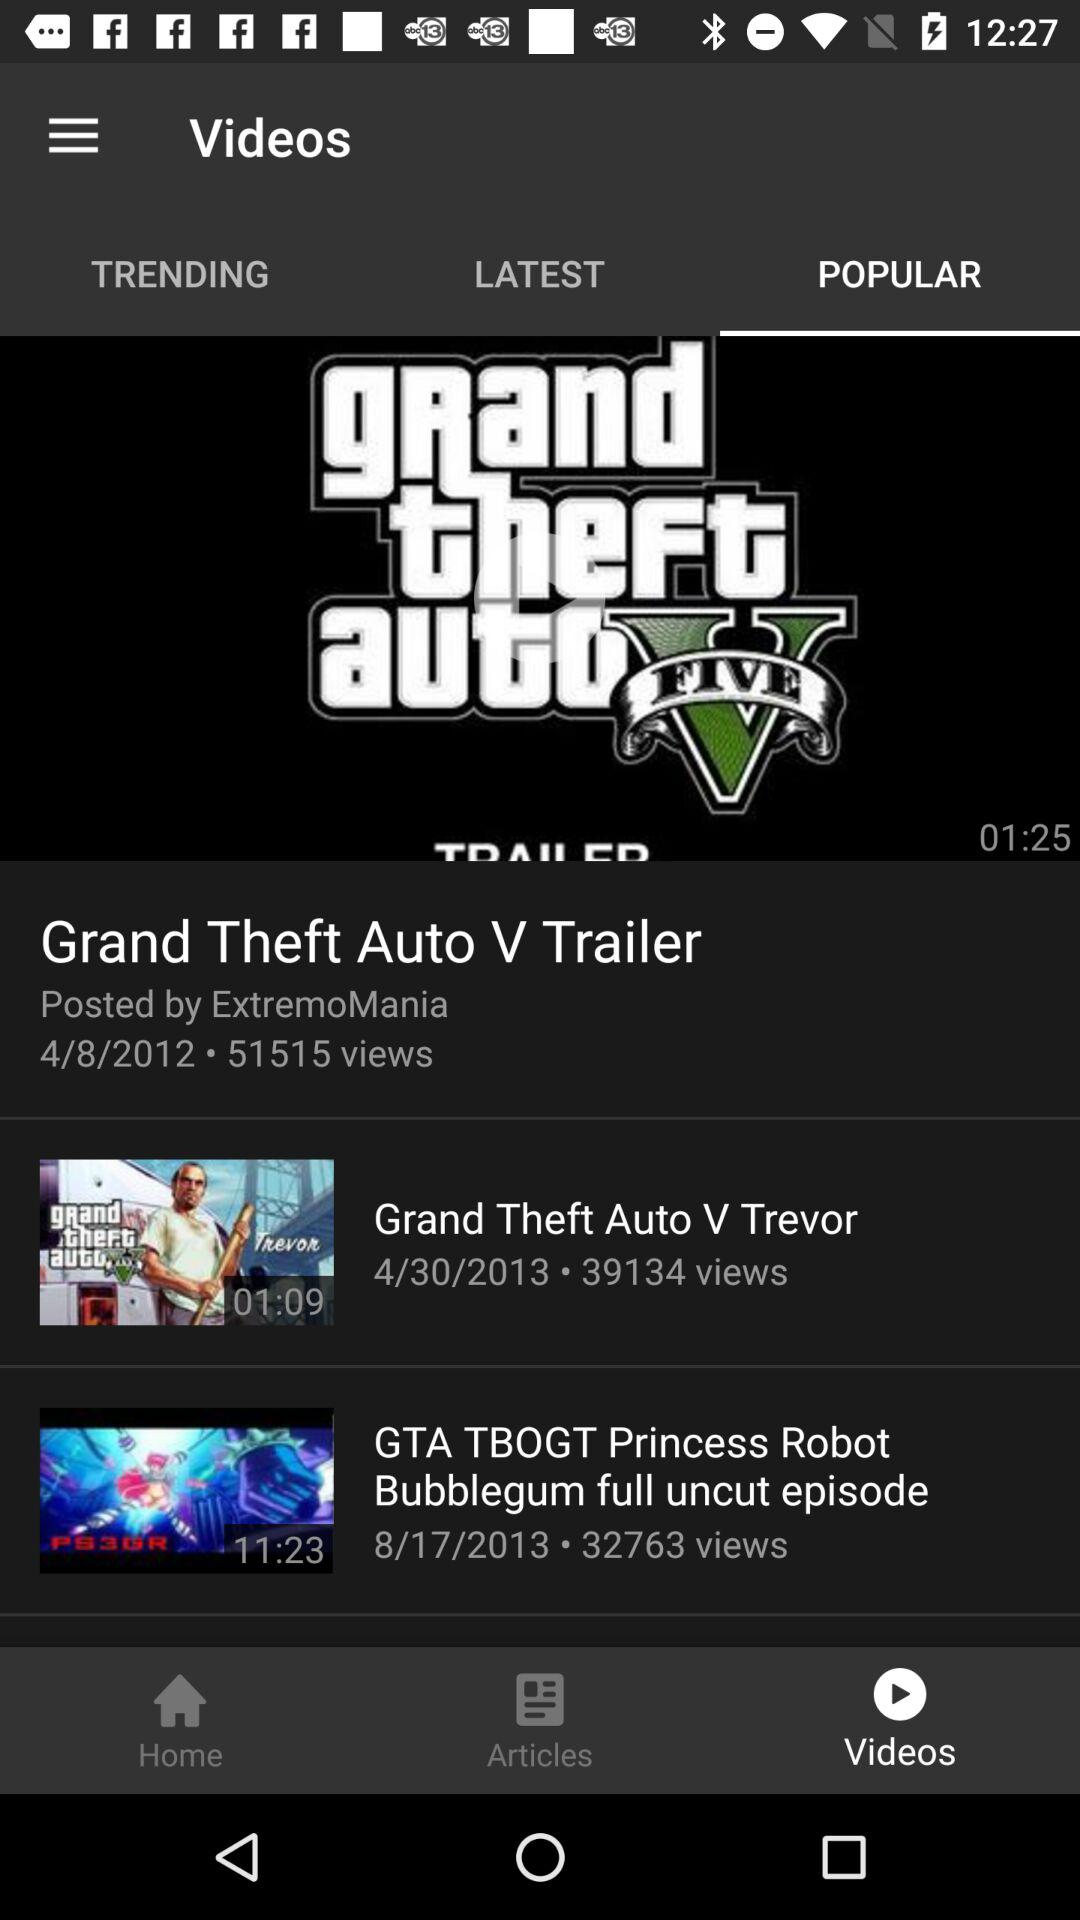Which tab is selected? The selected tabs are "Videos" and "POPULAR". 